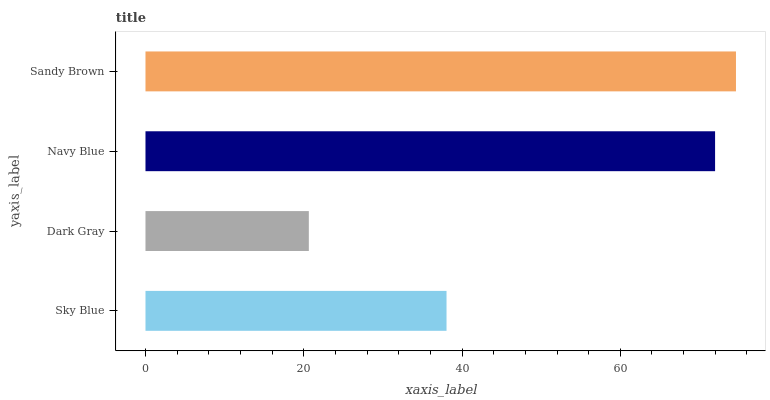Is Dark Gray the minimum?
Answer yes or no. Yes. Is Sandy Brown the maximum?
Answer yes or no. Yes. Is Navy Blue the minimum?
Answer yes or no. No. Is Navy Blue the maximum?
Answer yes or no. No. Is Navy Blue greater than Dark Gray?
Answer yes or no. Yes. Is Dark Gray less than Navy Blue?
Answer yes or no. Yes. Is Dark Gray greater than Navy Blue?
Answer yes or no. No. Is Navy Blue less than Dark Gray?
Answer yes or no. No. Is Navy Blue the high median?
Answer yes or no. Yes. Is Sky Blue the low median?
Answer yes or no. Yes. Is Dark Gray the high median?
Answer yes or no. No. Is Sandy Brown the low median?
Answer yes or no. No. 